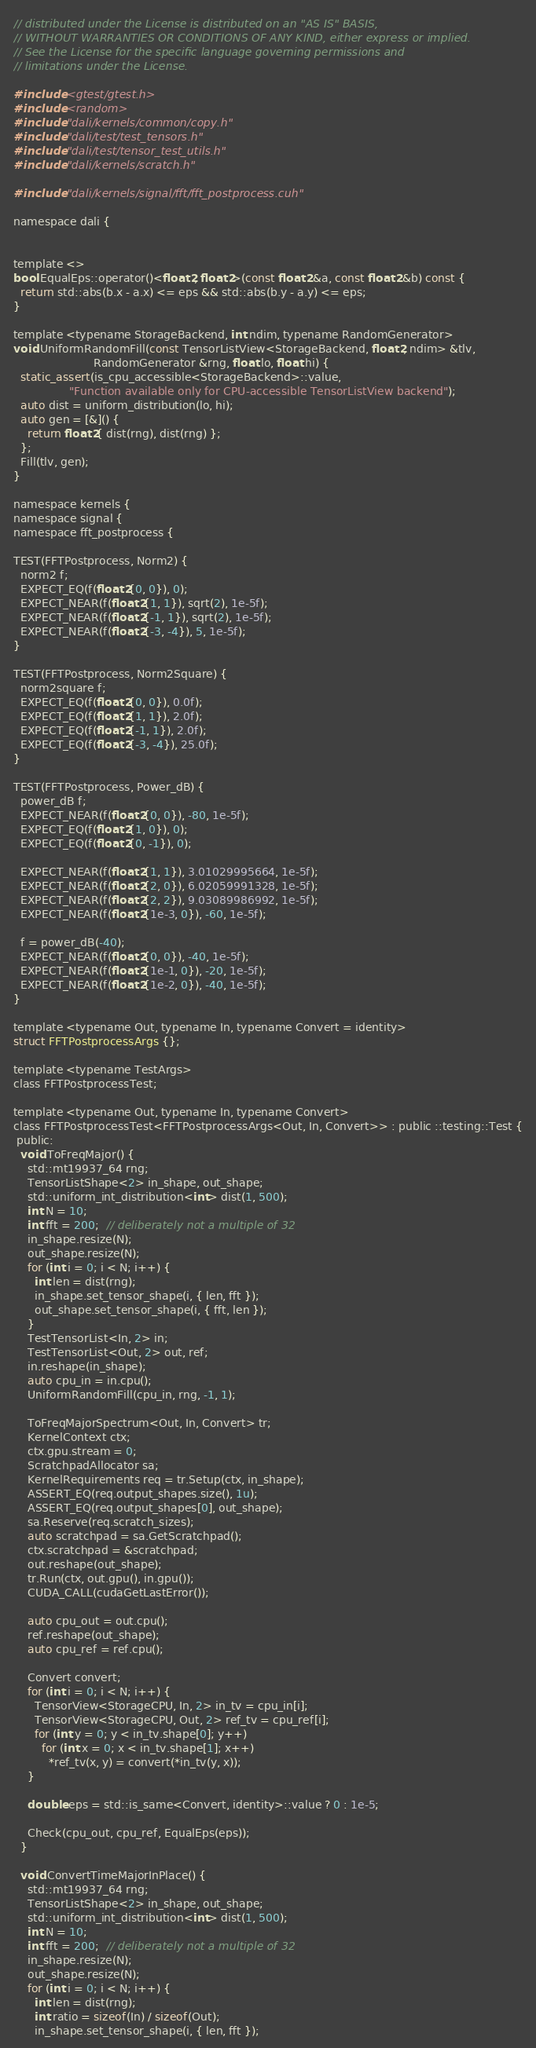<code> <loc_0><loc_0><loc_500><loc_500><_Cuda_>// distributed under the License is distributed on an "AS IS" BASIS,
// WITHOUT WARRANTIES OR CONDITIONS OF ANY KIND, either express or implied.
// See the License for the specific language governing permissions and
// limitations under the License.

#include <gtest/gtest.h>
#include <random>
#include "dali/kernels/common/copy.h"
#include "dali/test/test_tensors.h"
#include "dali/test/tensor_test_utils.h"
#include "dali/kernels/scratch.h"

#include "dali/kernels/signal/fft/fft_postprocess.cuh"

namespace dali {


template <>
bool EqualEps::operator()<float2, float2>(const float2 &a, const float2 &b) const {
  return std::abs(b.x - a.x) <= eps && std::abs(b.y - a.y) <= eps;
}

template <typename StorageBackend, int ndim, typename RandomGenerator>
void UniformRandomFill(const TensorListView<StorageBackend, float2, ndim> &tlv,
                       RandomGenerator &rng, float lo, float hi) {
  static_assert(is_cpu_accessible<StorageBackend>::value,
                "Function available only for CPU-accessible TensorListView backend");
  auto dist = uniform_distribution(lo, hi);
  auto gen = [&]() {
    return float2{ dist(rng), dist(rng) };
  };
  Fill(tlv, gen);
}

namespace kernels {
namespace signal {
namespace fft_postprocess {

TEST(FFTPostprocess, Norm2) {
  norm2 f;
  EXPECT_EQ(f(float2{0, 0}), 0);
  EXPECT_NEAR(f(float2{1, 1}), sqrt(2), 1e-5f);
  EXPECT_NEAR(f(float2{-1, 1}), sqrt(2), 1e-5f);
  EXPECT_NEAR(f(float2{-3, -4}), 5, 1e-5f);
}

TEST(FFTPostprocess, Norm2Square) {
  norm2square f;
  EXPECT_EQ(f(float2{0, 0}), 0.0f);
  EXPECT_EQ(f(float2{1, 1}), 2.0f);
  EXPECT_EQ(f(float2{-1, 1}), 2.0f);
  EXPECT_EQ(f(float2{-3, -4}), 25.0f);
}

TEST(FFTPostprocess, Power_dB) {
  power_dB f;
  EXPECT_NEAR(f(float2{0, 0}), -80, 1e-5f);
  EXPECT_EQ(f(float2{1, 0}), 0);
  EXPECT_EQ(f(float2{0, -1}), 0);

  EXPECT_NEAR(f(float2{1, 1}), 3.01029995664, 1e-5f);
  EXPECT_NEAR(f(float2{2, 0}), 6.02059991328, 1e-5f);
  EXPECT_NEAR(f(float2{2, 2}), 9.03089986992, 1e-5f);
  EXPECT_NEAR(f(float2{1e-3, 0}), -60, 1e-5f);

  f = power_dB(-40);
  EXPECT_NEAR(f(float2{0, 0}), -40, 1e-5f);
  EXPECT_NEAR(f(float2{1e-1, 0}), -20, 1e-5f);
  EXPECT_NEAR(f(float2{1e-2, 0}), -40, 1e-5f);
}

template <typename Out, typename In, typename Convert = identity>
struct FFTPostprocessArgs {};

template <typename TestArgs>
class FFTPostprocessTest;

template <typename Out, typename In, typename Convert>
class FFTPostprocessTest<FFTPostprocessArgs<Out, In, Convert>> : public ::testing::Test {
 public:
  void ToFreqMajor() {
    std::mt19937_64 rng;
    TensorListShape<2> in_shape, out_shape;
    std::uniform_int_distribution<int> dist(1, 500);
    int N = 10;
    int fft = 200;  // deliberately not a multiple of 32
    in_shape.resize(N);
    out_shape.resize(N);
    for (int i = 0; i < N; i++) {
      int len = dist(rng);
      in_shape.set_tensor_shape(i, { len, fft });
      out_shape.set_tensor_shape(i, { fft, len });
    }
    TestTensorList<In, 2> in;
    TestTensorList<Out, 2> out, ref;
    in.reshape(in_shape);
    auto cpu_in = in.cpu();
    UniformRandomFill(cpu_in, rng, -1, 1);

    ToFreqMajorSpectrum<Out, In, Convert> tr;
    KernelContext ctx;
    ctx.gpu.stream = 0;
    ScratchpadAllocator sa;
    KernelRequirements req = tr.Setup(ctx, in_shape);
    ASSERT_EQ(req.output_shapes.size(), 1u);
    ASSERT_EQ(req.output_shapes[0], out_shape);
    sa.Reserve(req.scratch_sizes);
    auto scratchpad = sa.GetScratchpad();
    ctx.scratchpad = &scratchpad;
    out.reshape(out_shape);
    tr.Run(ctx, out.gpu(), in.gpu());
    CUDA_CALL(cudaGetLastError());

    auto cpu_out = out.cpu();
    ref.reshape(out_shape);
    auto cpu_ref = ref.cpu();

    Convert convert;
    for (int i = 0; i < N; i++) {
      TensorView<StorageCPU, In, 2> in_tv = cpu_in[i];
      TensorView<StorageCPU, Out, 2> ref_tv = cpu_ref[i];
      for (int y = 0; y < in_tv.shape[0]; y++)
        for (int x = 0; x < in_tv.shape[1]; x++)
          *ref_tv(x, y) = convert(*in_tv(y, x));
    }

    double eps = std::is_same<Convert, identity>::value ? 0 : 1e-5;

    Check(cpu_out, cpu_ref, EqualEps(eps));
  }

  void ConvertTimeMajorInPlace() {
    std::mt19937_64 rng;
    TensorListShape<2> in_shape, out_shape;
    std::uniform_int_distribution<int> dist(1, 500);
    int N = 10;
    int fft = 200;  // deliberately not a multiple of 32
    in_shape.resize(N);
    out_shape.resize(N);
    for (int i = 0; i < N; i++) {
      int len = dist(rng);
      int ratio = sizeof(In) / sizeof(Out);
      in_shape.set_tensor_shape(i, { len, fft });</code> 